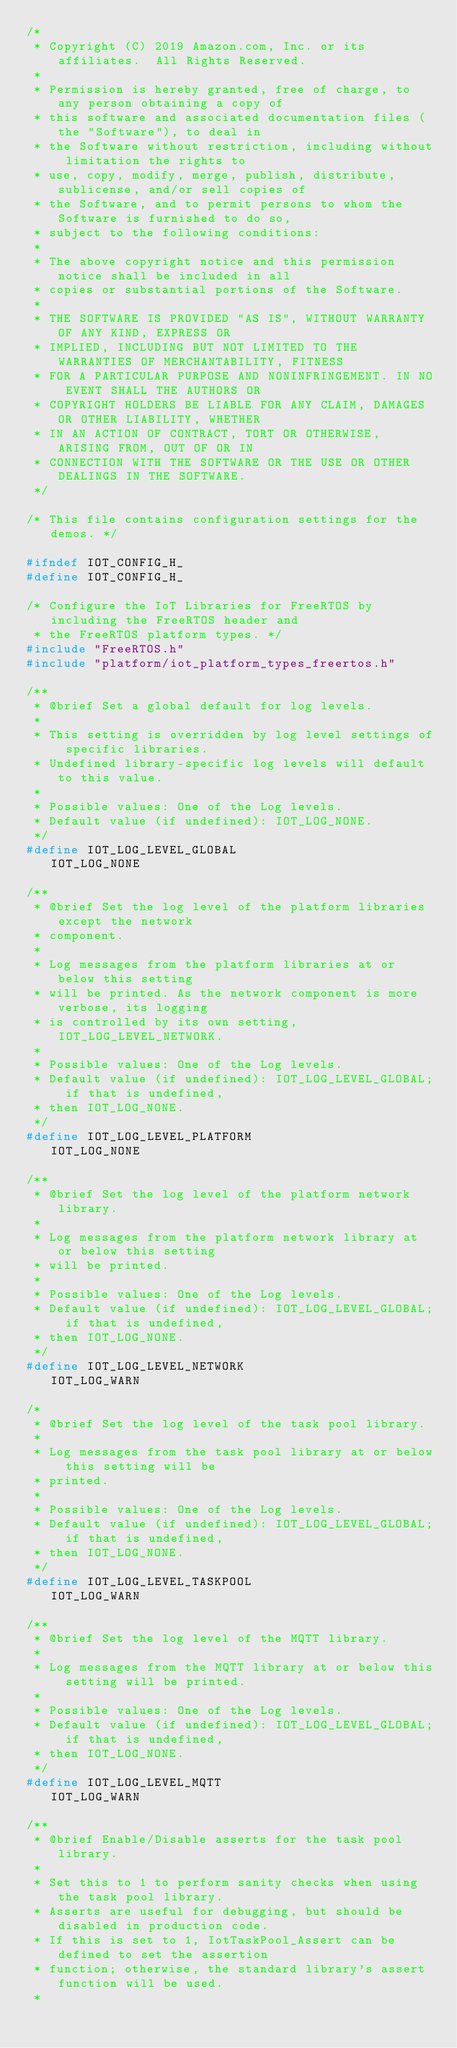Convert code to text. <code><loc_0><loc_0><loc_500><loc_500><_C_>/*
 * Copyright (C) 2019 Amazon.com, Inc. or its affiliates.  All Rights Reserved.
 *
 * Permission is hereby granted, free of charge, to any person obtaining a copy of
 * this software and associated documentation files (the "Software"), to deal in
 * the Software without restriction, including without limitation the rights to
 * use, copy, modify, merge, publish, distribute, sublicense, and/or sell copies of
 * the Software, and to permit persons to whom the Software is furnished to do so,
 * subject to the following conditions:
 *
 * The above copyright notice and this permission notice shall be included in all
 * copies or substantial portions of the Software.
 *
 * THE SOFTWARE IS PROVIDED "AS IS", WITHOUT WARRANTY OF ANY KIND, EXPRESS OR
 * IMPLIED, INCLUDING BUT NOT LIMITED TO THE WARRANTIES OF MERCHANTABILITY, FITNESS
 * FOR A PARTICULAR PURPOSE AND NONINFRINGEMENT. IN NO EVENT SHALL THE AUTHORS OR
 * COPYRIGHT HOLDERS BE LIABLE FOR ANY CLAIM, DAMAGES OR OTHER LIABILITY, WHETHER
 * IN AN ACTION OF CONTRACT, TORT OR OTHERWISE, ARISING FROM, OUT OF OR IN
 * CONNECTION WITH THE SOFTWARE OR THE USE OR OTHER DEALINGS IN THE SOFTWARE.
 */

/* This file contains configuration settings for the demos. */

#ifndef IOT_CONFIG_H_
#define IOT_CONFIG_H_

/* Configure the IoT Libraries for FreeRTOS by including the FreeRTOS header and
 * the FreeRTOS platform types. */
#include "FreeRTOS.h"
#include "platform/iot_platform_types_freertos.h"

/**
 * @brief Set a global default for log levels.
 *
 * This setting is overridden by log level settings of specific libraries.
 * Undefined library-specific log levels will default to this value.
 *
 * Possible values: One of the Log levels.
 * Default value (if undefined): IOT_LOG_NONE.
 */
#define IOT_LOG_LEVEL_GLOBAL                    IOT_LOG_NONE

/**
 * @brief Set the log level of the platform libraries except the network
 * component.
 *
 * Log messages from the platform libraries at or below this setting
 * will be printed. As the network component is more verbose, its logging
 * is controlled by its own setting, IOT_LOG_LEVEL_NETWORK.
 *
 * Possible values: One of the Log levels.
 * Default value (if undefined): IOT_LOG_LEVEL_GLOBAL; if that is undefined,
 * then IOT_LOG_NONE.
 */
#define IOT_LOG_LEVEL_PLATFORM                  IOT_LOG_NONE

/**
 * @brief Set the log level of the platform network library.
 *
 * Log messages from the platform network library at or below this setting
 * will be printed.
 *
 * Possible values: One of the Log levels.
 * Default value (if undefined): IOT_LOG_LEVEL_GLOBAL; if that is undefined,
 * then IOT_LOG_NONE.
 */
#define IOT_LOG_LEVEL_NETWORK                   IOT_LOG_WARN

/*
 * @brief Set the log level of the task pool library.
 *
 * Log messages from the task pool library at or below this setting will be
 * printed.
 *
 * Possible values: One of the Log levels.
 * Default value (if undefined): IOT_LOG_LEVEL_GLOBAL; if that is undefined,
 * then IOT_LOG_NONE.
 */
#define IOT_LOG_LEVEL_TASKPOOL                  IOT_LOG_WARN

/**
 * @brief Set the log level of the MQTT library.
 *
 * Log messages from the MQTT library at or below this setting will be printed.
 *
 * Possible values: One of the Log levels.
 * Default value (if undefined): IOT_LOG_LEVEL_GLOBAL; if that is undefined,
 * then IOT_LOG_NONE.
 */
#define IOT_LOG_LEVEL_MQTT                      IOT_LOG_WARN

/**
 * @brief Enable/Disable asserts for the task pool library.
 *
 * Set this to 1 to perform sanity checks when using the task pool library.
 * Asserts are useful for debugging, but should be disabled in production code.
 * If this is set to 1, IotTaskPool_Assert can be defined to set the assertion
 * function; otherwise, the standard library's assert function will be used.
 *</code> 